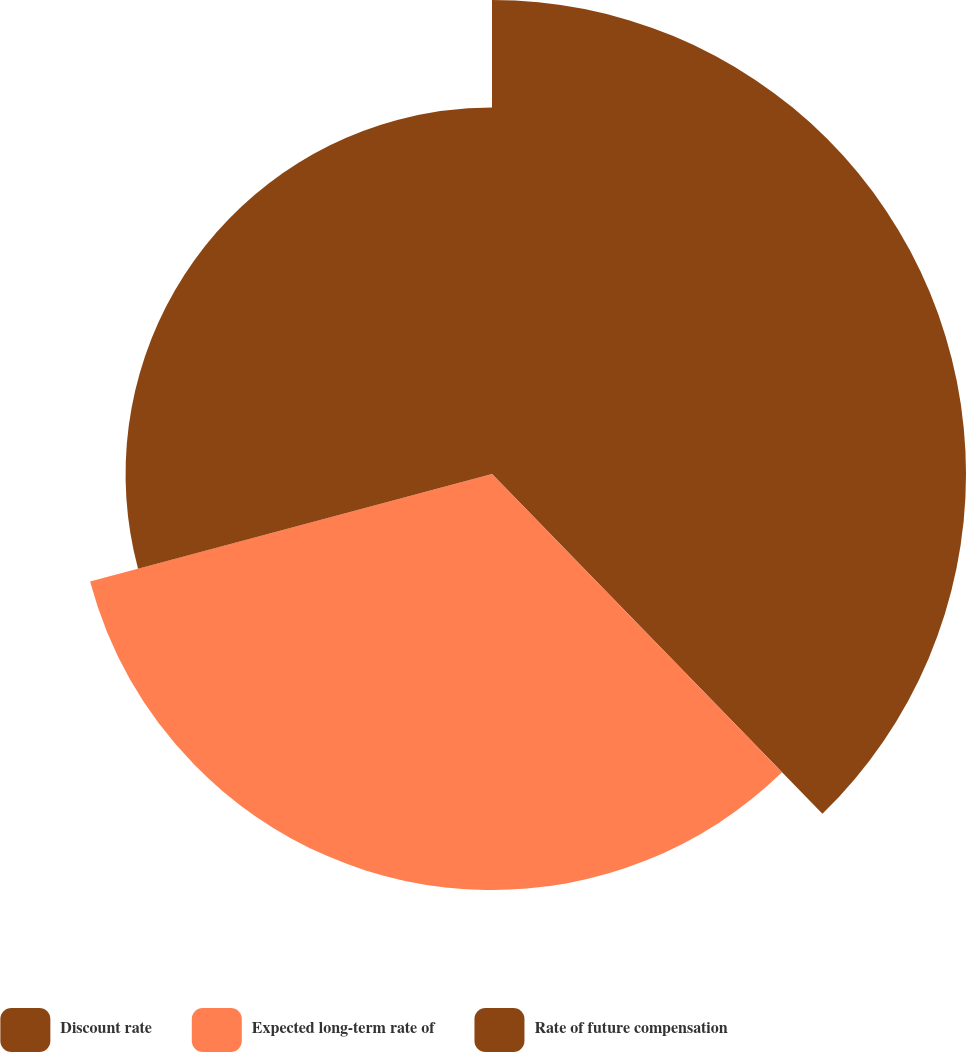<chart> <loc_0><loc_0><loc_500><loc_500><pie_chart><fcel>Discount rate<fcel>Expected long-term rate of<fcel>Rate of future compensation<nl><fcel>37.72%<fcel>33.11%<fcel>29.16%<nl></chart> 